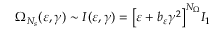<formula> <loc_0><loc_0><loc_500><loc_500>\Omega _ { N _ { s } } ( \varepsilon , \gamma ) \sim I ( \varepsilon , \gamma ) = \left [ \varepsilon + b _ { \varepsilon } \gamma ^ { 2 } \right ] ^ { N _ { \Omega } } I _ { 1 }</formula> 